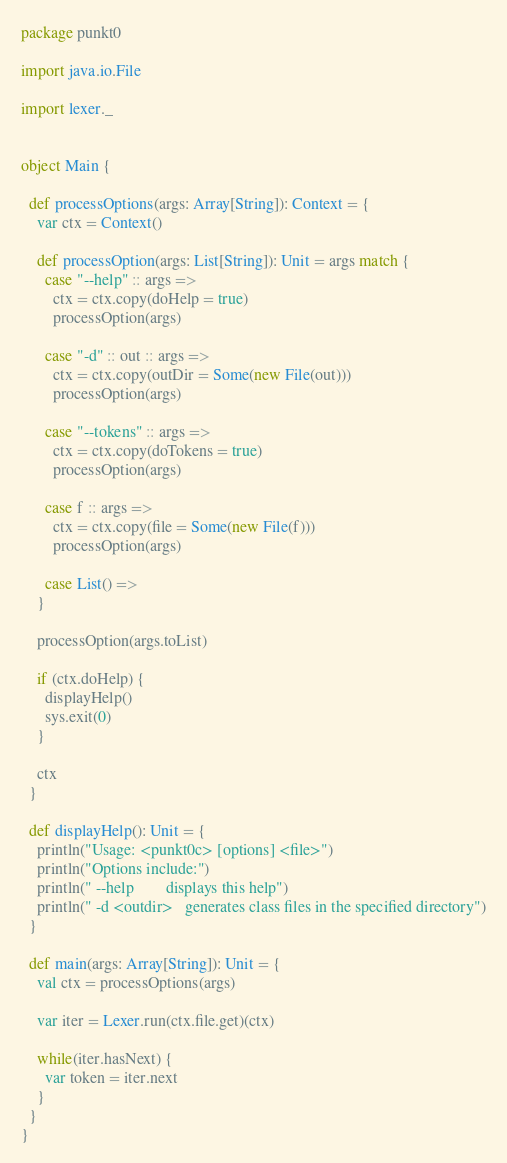Convert code to text. <code><loc_0><loc_0><loc_500><loc_500><_Scala_>package punkt0

import java.io.File

import lexer._


object Main {

  def processOptions(args: Array[String]): Context = {
    var ctx = Context()

    def processOption(args: List[String]): Unit = args match {
      case "--help" :: args =>
        ctx = ctx.copy(doHelp = true)
        processOption(args)

      case "-d" :: out :: args =>
        ctx = ctx.copy(outDir = Some(new File(out)))
        processOption(args)

      case "--tokens" :: args =>
        ctx = ctx.copy(doTokens = true)
        processOption(args)

      case f :: args =>
        ctx = ctx.copy(file = Some(new File(f)))
        processOption(args)

      case List() =>
    }

    processOption(args.toList)

    if (ctx.doHelp) {
      displayHelp()
      sys.exit(0)
    }

    ctx
  }

  def displayHelp(): Unit = {
    println("Usage: <punkt0c> [options] <file>")
    println("Options include:")
    println(" --help        displays this help")
    println(" -d <outdir>   generates class files in the specified directory")
  }

  def main(args: Array[String]): Unit = {
    val ctx = processOptions(args)
    
    var iter = Lexer.run(ctx.file.get)(ctx)

    while(iter.hasNext) {
      var token = iter.next
    }
  }
}
</code> 